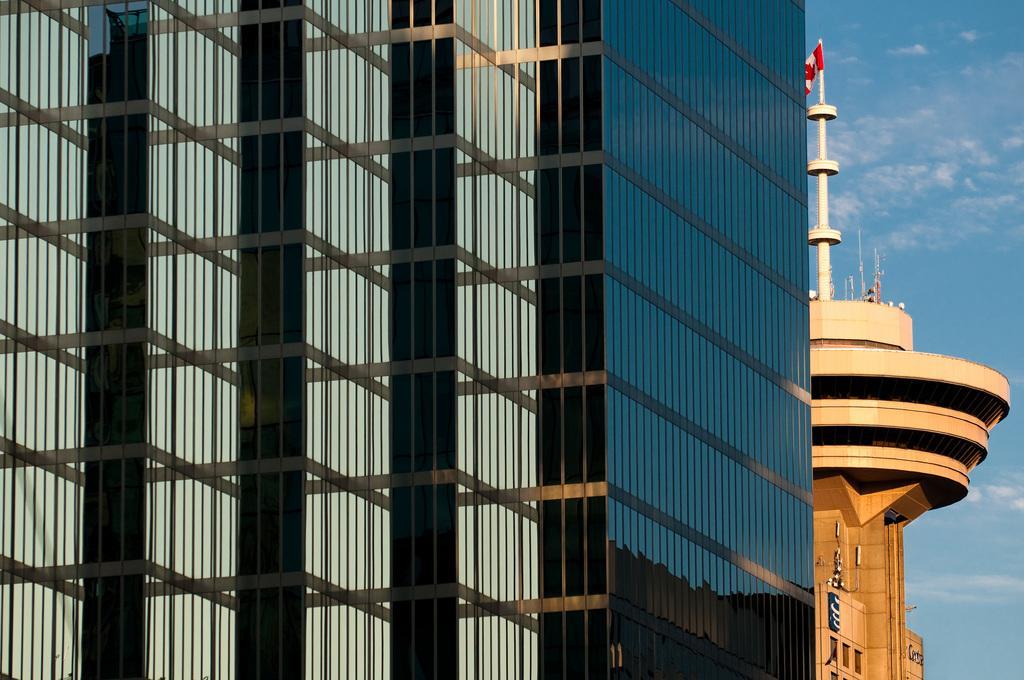In one or two sentences, can you explain what this image depicts? In front of the image there are buildings. On top of the building there is a flag. In the background of the image there is sky. 